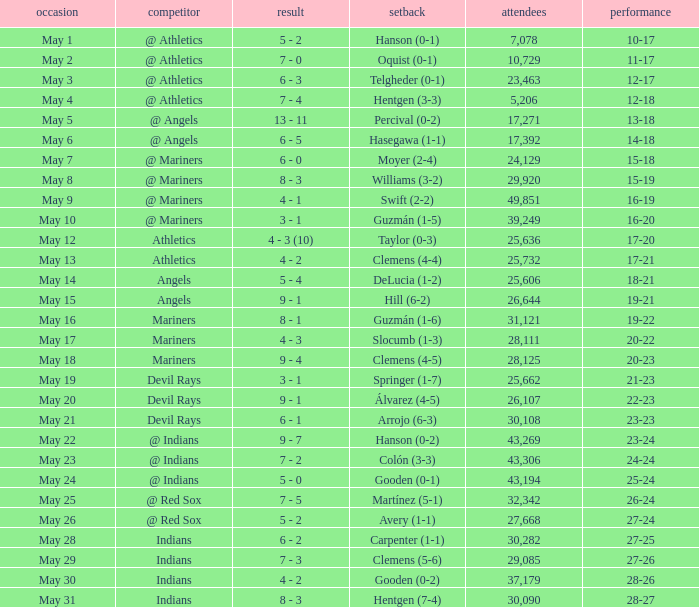Who lost on May 31? Hentgen (7-4). 